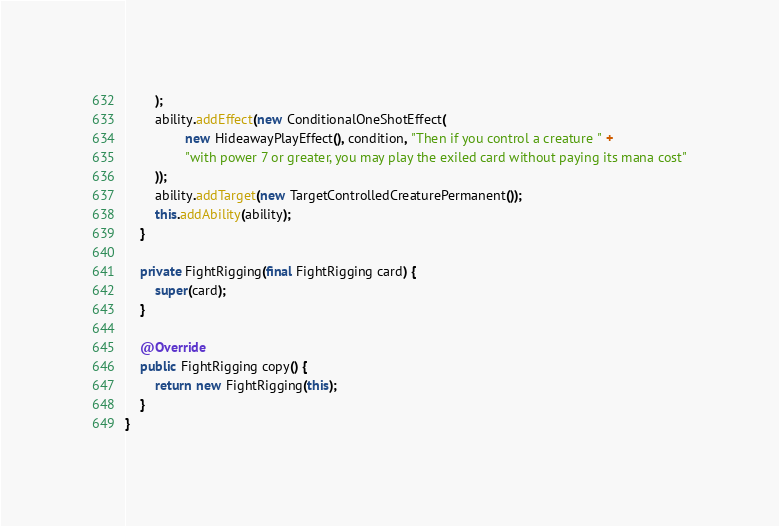<code> <loc_0><loc_0><loc_500><loc_500><_Java_>        );
        ability.addEffect(new ConditionalOneShotEffect(
                new HideawayPlayEffect(), condition, "Then if you control a creature " +
                "with power 7 or greater, you may play the exiled card without paying its mana cost"
        ));
        ability.addTarget(new TargetControlledCreaturePermanent());
        this.addAbility(ability);
    }

    private FightRigging(final FightRigging card) {
        super(card);
    }

    @Override
    public FightRigging copy() {
        return new FightRigging(this);
    }
}
</code> 